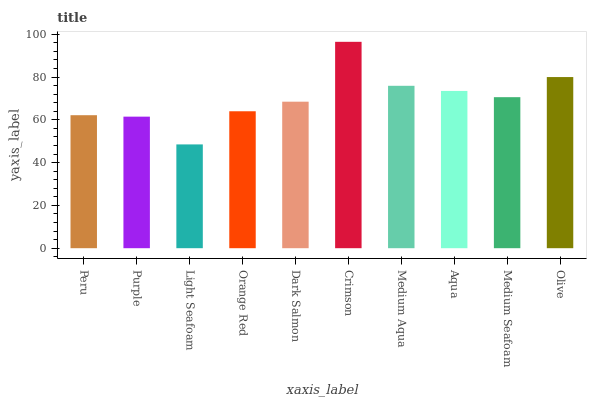Is Light Seafoam the minimum?
Answer yes or no. Yes. Is Crimson the maximum?
Answer yes or no. Yes. Is Purple the minimum?
Answer yes or no. No. Is Purple the maximum?
Answer yes or no. No. Is Peru greater than Purple?
Answer yes or no. Yes. Is Purple less than Peru?
Answer yes or no. Yes. Is Purple greater than Peru?
Answer yes or no. No. Is Peru less than Purple?
Answer yes or no. No. Is Medium Seafoam the high median?
Answer yes or no. Yes. Is Dark Salmon the low median?
Answer yes or no. Yes. Is Dark Salmon the high median?
Answer yes or no. No. Is Purple the low median?
Answer yes or no. No. 